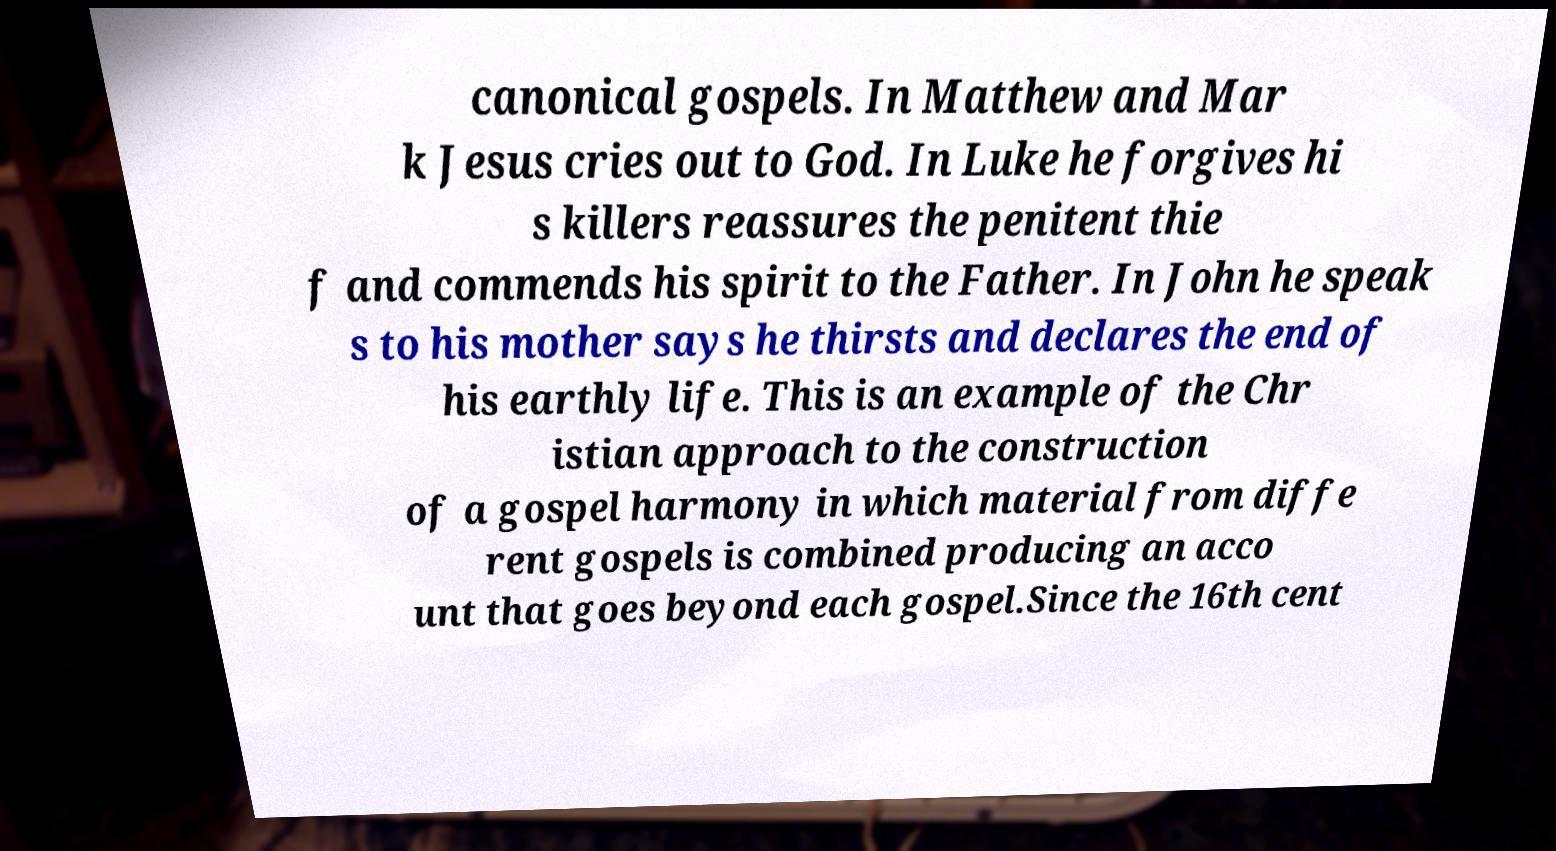Can you read and provide the text displayed in the image?This photo seems to have some interesting text. Can you extract and type it out for me? canonical gospels. In Matthew and Mar k Jesus cries out to God. In Luke he forgives hi s killers reassures the penitent thie f and commends his spirit to the Father. In John he speak s to his mother says he thirsts and declares the end of his earthly life. This is an example of the Chr istian approach to the construction of a gospel harmony in which material from diffe rent gospels is combined producing an acco unt that goes beyond each gospel.Since the 16th cent 